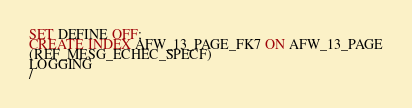<code> <loc_0><loc_0><loc_500><loc_500><_SQL_>SET DEFINE OFF;
CREATE INDEX AFW_13_PAGE_FK7 ON AFW_13_PAGE
(REF_MESG_ECHEC_SPECF)
LOGGING
/
</code> 